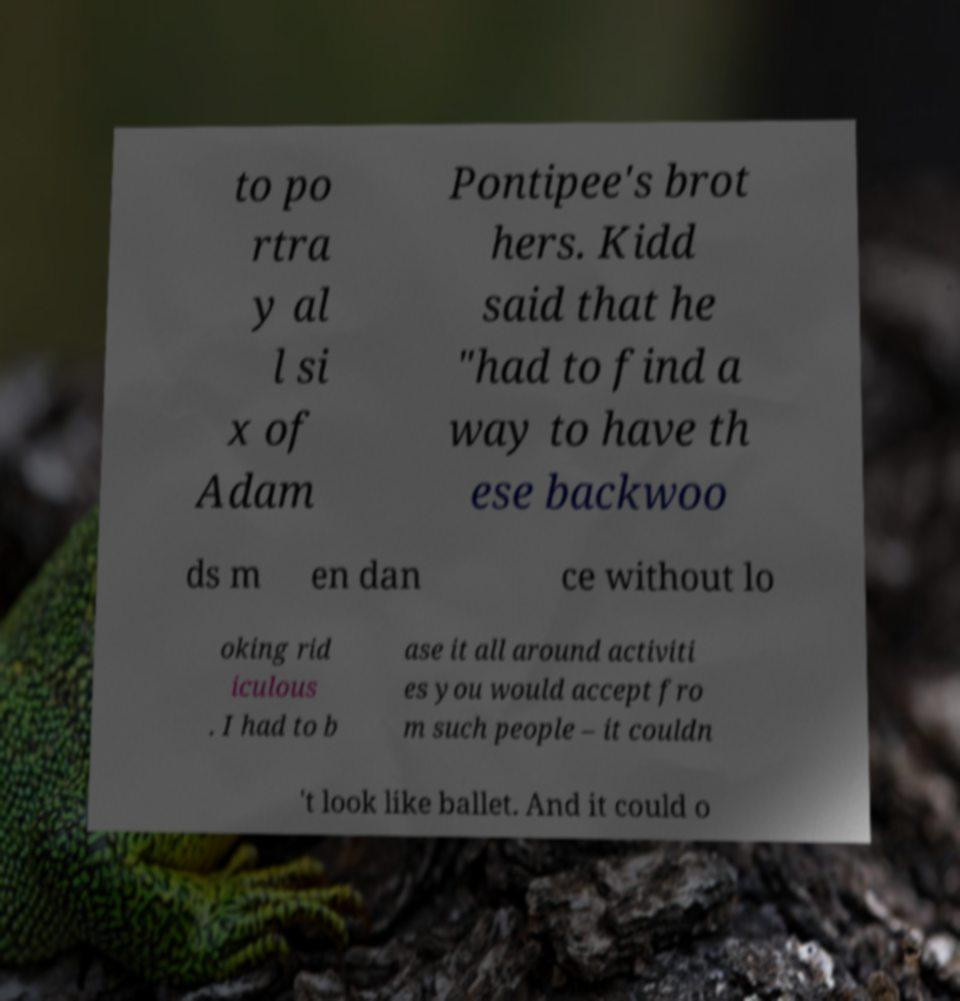Could you assist in decoding the text presented in this image and type it out clearly? to po rtra y al l si x of Adam Pontipee's brot hers. Kidd said that he "had to find a way to have th ese backwoo ds m en dan ce without lo oking rid iculous . I had to b ase it all around activiti es you would accept fro m such people – it couldn 't look like ballet. And it could o 